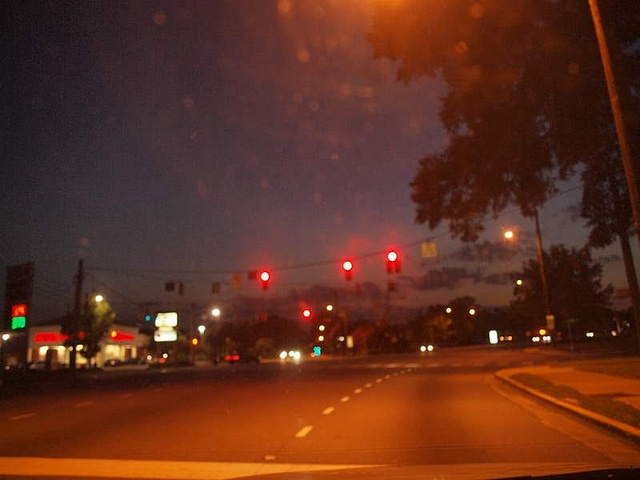Describe the objects in this image and their specific colors. I can see traffic light in black, lightgreen, maroon, and red tones, traffic light in black, maroon, and teal tones, car in black, maroon, and brown tones, car in black, maroon, brown, and red tones, and car in black, maroon, and ivory tones in this image. 